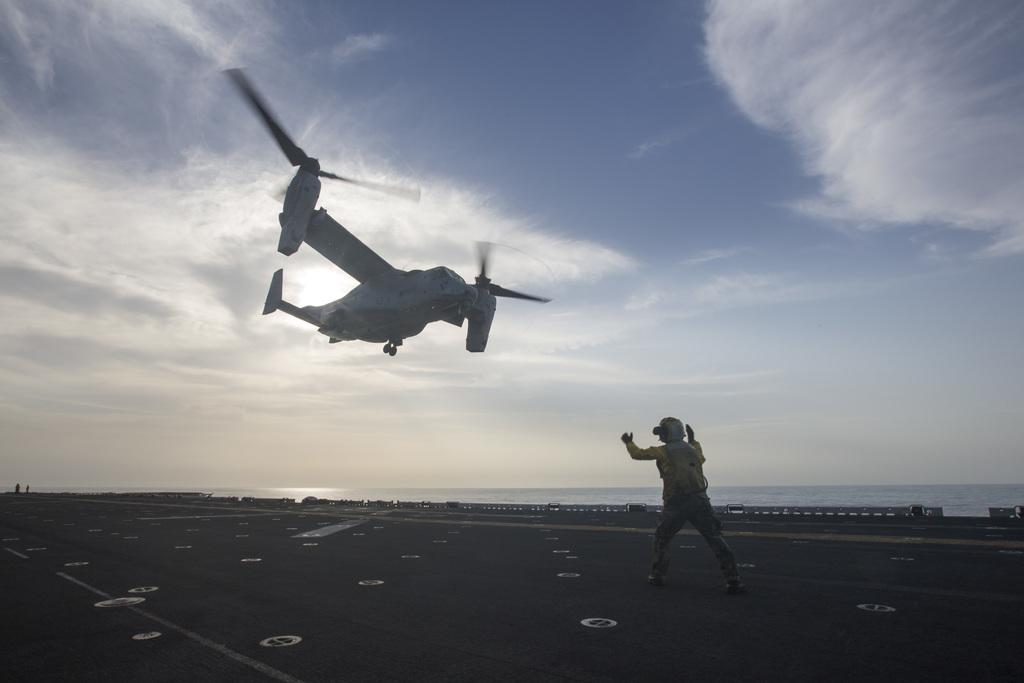What is the man in the image doing? The man is standing on the road. What else can be seen in the sky besides clouds? There is an aircraft flying in the air. Can you describe the sky in the image? Clouds are visible in the sky. What songs is the man's father singing to him in the image? There is no mention of a father or any songs in the image; it only features a man standing on the road and an aircraft flying in the air. 